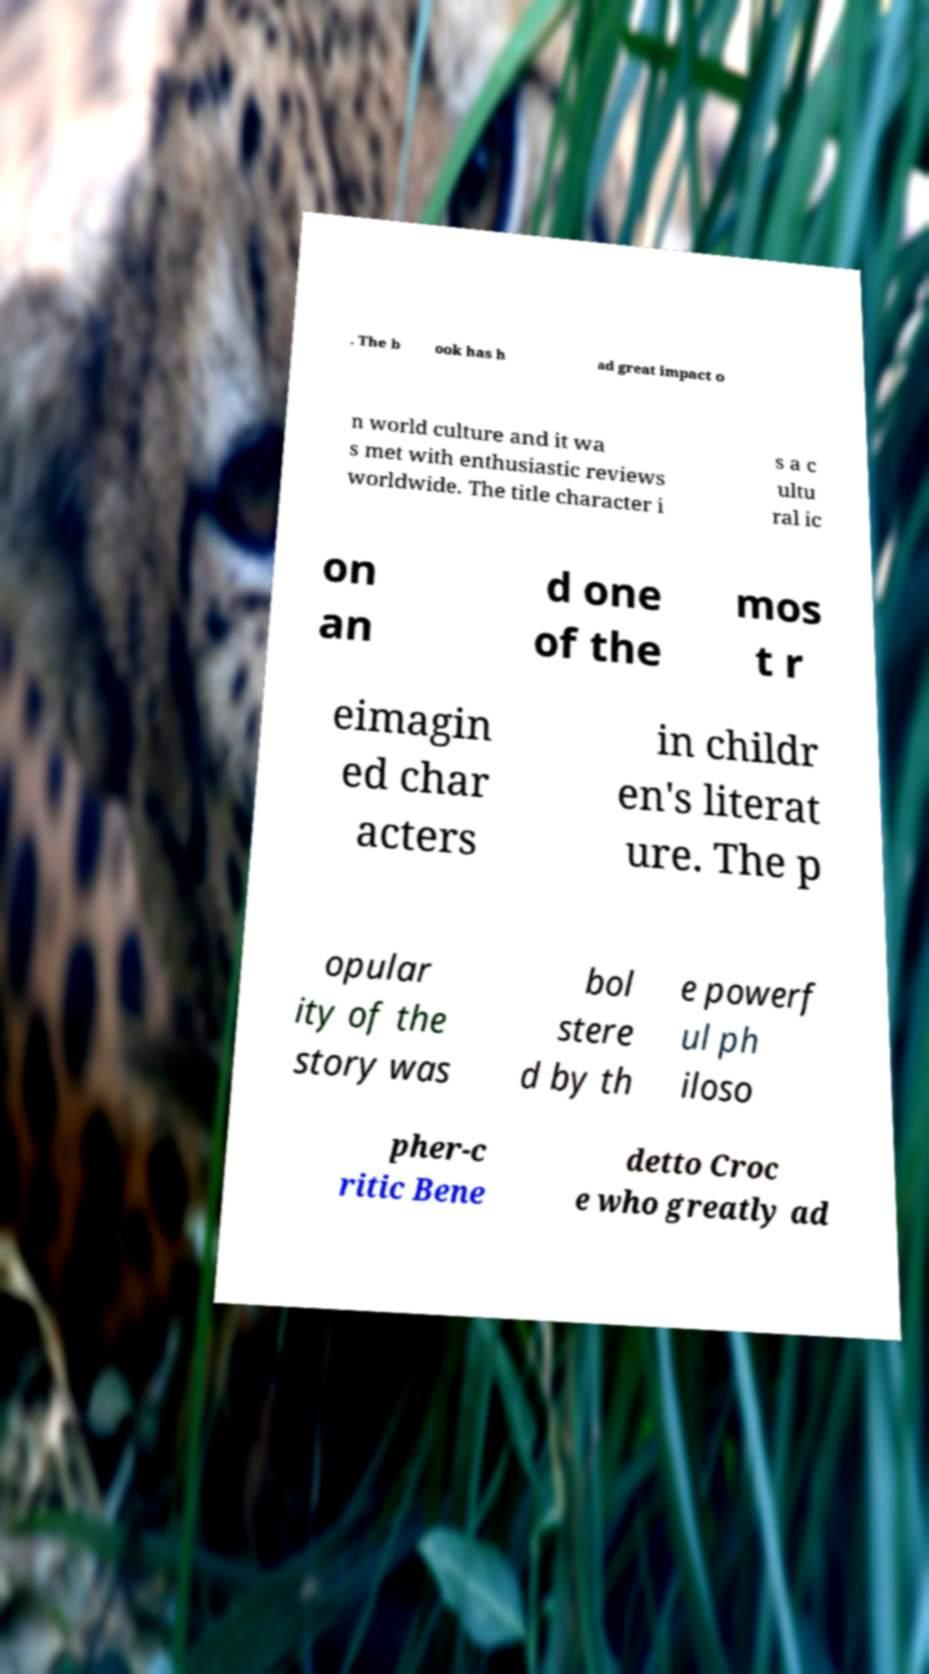What messages or text are displayed in this image? I need them in a readable, typed format. . The b ook has h ad great impact o n world culture and it wa s met with enthusiastic reviews worldwide. The title character i s a c ultu ral ic on an d one of the mos t r eimagin ed char acters in childr en's literat ure. The p opular ity of the story was bol stere d by th e powerf ul ph iloso pher-c ritic Bene detto Croc e who greatly ad 